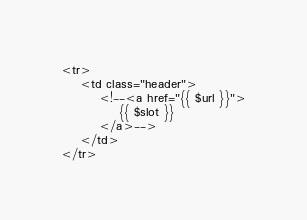Convert code to text. <code><loc_0><loc_0><loc_500><loc_500><_PHP_><tr>
    <td class="header">
        <!--<a href="{{ $url }}">
            {{ $slot }}
        </a>-->
    </td>
</tr>
</code> 